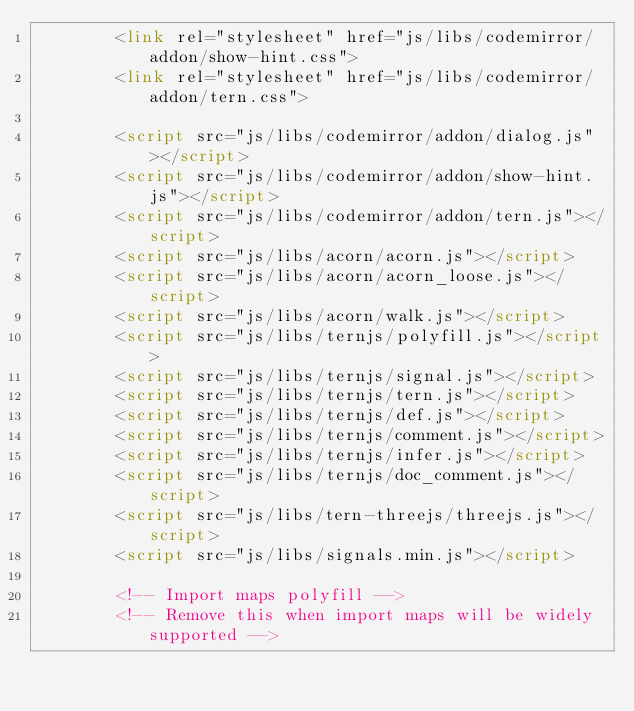Convert code to text. <code><loc_0><loc_0><loc_500><loc_500><_HTML_>		<link rel="stylesheet" href="js/libs/codemirror/addon/show-hint.css">
		<link rel="stylesheet" href="js/libs/codemirror/addon/tern.css">

		<script src="js/libs/codemirror/addon/dialog.js"></script>
		<script src="js/libs/codemirror/addon/show-hint.js"></script>
		<script src="js/libs/codemirror/addon/tern.js"></script>
		<script src="js/libs/acorn/acorn.js"></script>
		<script src="js/libs/acorn/acorn_loose.js"></script>
		<script src="js/libs/acorn/walk.js"></script>
		<script src="js/libs/ternjs/polyfill.js"></script>
		<script src="js/libs/ternjs/signal.js"></script>
		<script src="js/libs/ternjs/tern.js"></script>
		<script src="js/libs/ternjs/def.js"></script>
		<script src="js/libs/ternjs/comment.js"></script>
		<script src="js/libs/ternjs/infer.js"></script>
		<script src="js/libs/ternjs/doc_comment.js"></script>
		<script src="js/libs/tern-threejs/threejs.js"></script>
		<script src="js/libs/signals.min.js"></script>

		<!-- Import maps polyfill -->
		<!-- Remove this when import maps will be widely supported --></code> 